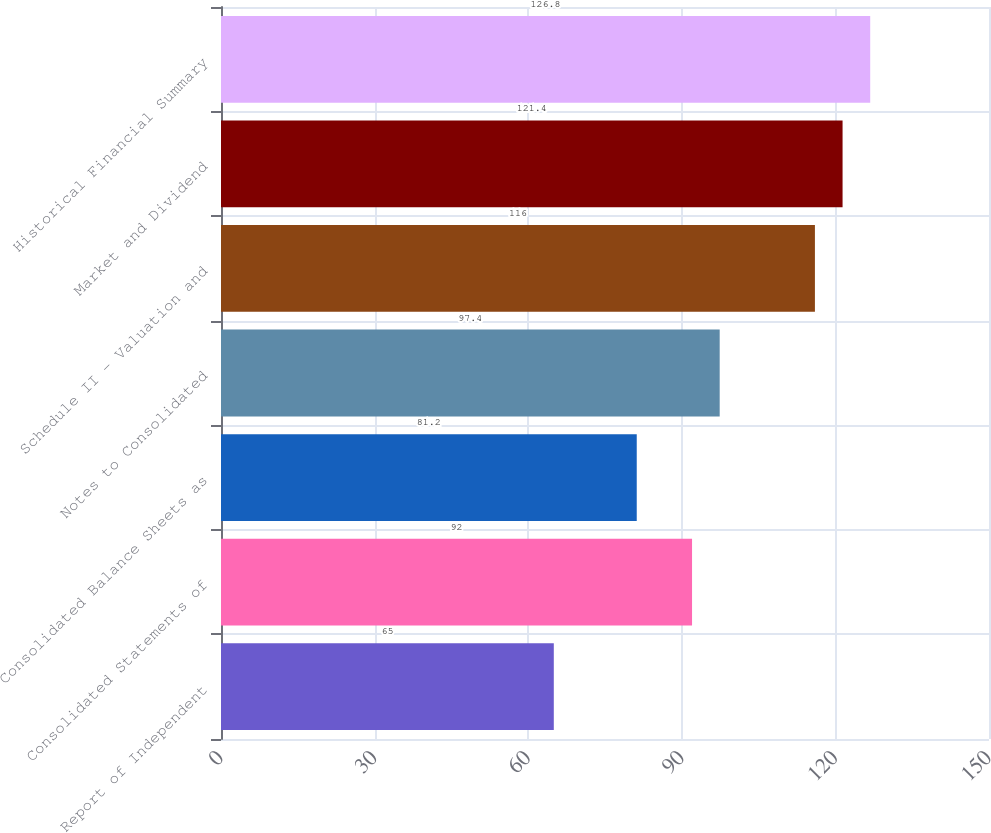Convert chart to OTSL. <chart><loc_0><loc_0><loc_500><loc_500><bar_chart><fcel>Report of Independent<fcel>Consolidated Statements of<fcel>Consolidated Balance Sheets as<fcel>Notes to Consolidated<fcel>Schedule II - Valuation and<fcel>Market and Dividend<fcel>Historical Financial Summary<nl><fcel>65<fcel>92<fcel>81.2<fcel>97.4<fcel>116<fcel>121.4<fcel>126.8<nl></chart> 